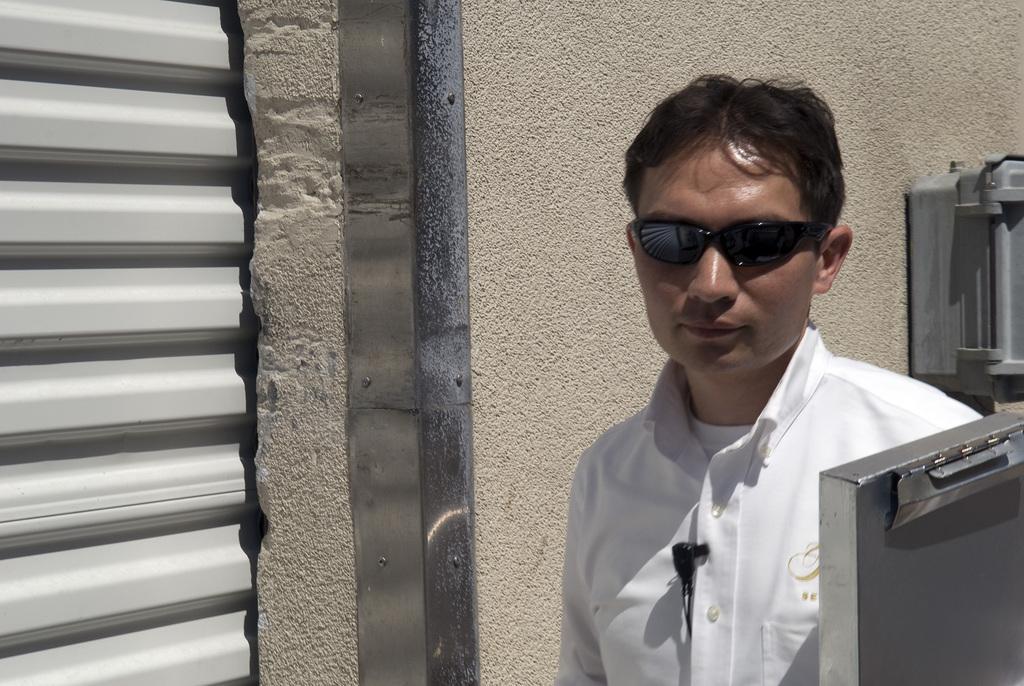Describe this image in one or two sentences. Here we can see a man and he has goggles. In the background there is a wall. 